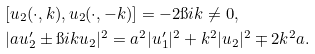Convert formula to latex. <formula><loc_0><loc_0><loc_500><loc_500>& [ u _ { 2 } ( \cdot , k ) , u _ { 2 } ( \cdot , - k ) ] = - 2 \i i k \ne 0 , \\ & | a u ^ { \prime } _ { 2 } \pm \i i k u _ { 2 } | ^ { 2 } = a ^ { 2 } | u ^ { \prime } _ { 1 } | ^ { 2 } + k ^ { 2 } | u _ { 2 } | ^ { 2 } \mp 2 k ^ { 2 } a .</formula> 